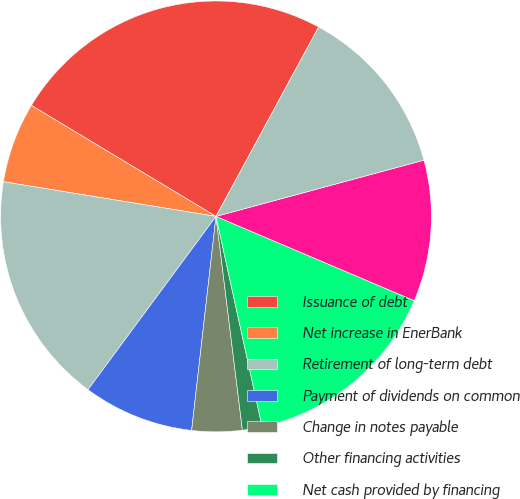Convert chart to OTSL. <chart><loc_0><loc_0><loc_500><loc_500><pie_chart><fcel>Issuance of debt<fcel>Net increase in EnerBank<fcel>Retirement of long-term debt<fcel>Payment of dividends on common<fcel>Change in notes payable<fcel>Other financing activities<fcel>Net cash provided by financing<fcel>Stockholder contribution from<fcel>Net cash provided by (used in)<nl><fcel>24.29%<fcel>6.04%<fcel>17.45%<fcel>8.32%<fcel>3.76%<fcel>1.48%<fcel>15.17%<fcel>10.6%<fcel>12.89%<nl></chart> 